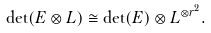Convert formula to latex. <formula><loc_0><loc_0><loc_500><loc_500>\det ( E \otimes L ) \cong \det ( E ) \otimes L ^ { \otimes r ^ { 2 } } .</formula> 